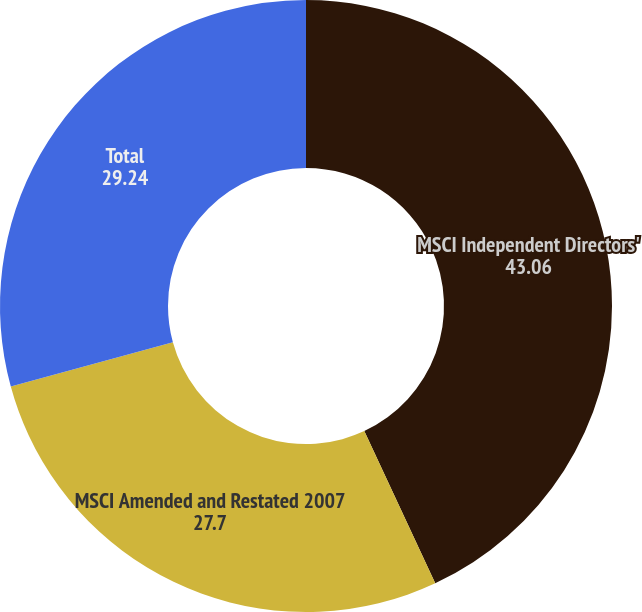Convert chart to OTSL. <chart><loc_0><loc_0><loc_500><loc_500><pie_chart><fcel>MSCI Independent Directors'<fcel>MSCI Amended and Restated 2007<fcel>Total<nl><fcel>43.06%<fcel>27.7%<fcel>29.24%<nl></chart> 